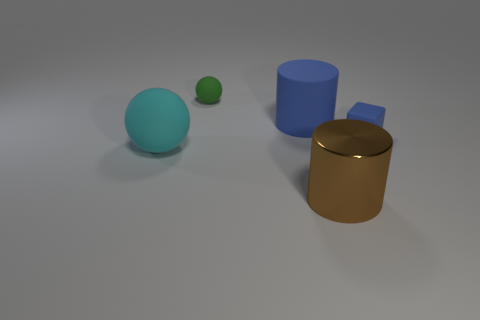What number of matte things are behind the cyan rubber object and to the left of the brown shiny cylinder?
Offer a very short reply. 2. Is there anything else of the same color as the tiny ball?
Ensure brevity in your answer.  No. There is a big blue object that is the same material as the big ball; what is its shape?
Your response must be concise. Cylinder. Do the rubber cylinder and the blue matte block have the same size?
Offer a terse response. No. Are the large cylinder that is behind the brown cylinder and the large ball made of the same material?
Offer a very short reply. Yes. Is there anything else that is made of the same material as the cube?
Provide a succinct answer. Yes. How many large cylinders are to the right of the ball that is behind the cyan object that is on the left side of the big brown object?
Keep it short and to the point. 2. Do the blue thing that is behind the blue cube and the big brown shiny object have the same shape?
Your answer should be compact. Yes. How many objects are either large red shiny blocks or big matte objects that are to the left of the big blue thing?
Your answer should be very brief. 1. Is the number of cylinders that are behind the cyan sphere greater than the number of blue rubber things?
Your response must be concise. No. 